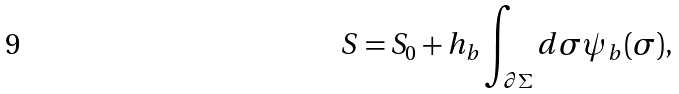<formula> <loc_0><loc_0><loc_500><loc_500>S = S _ { 0 } + h _ { b } \int _ { \partial \Sigma } d \sigma \psi _ { b } ( \sigma ) ,</formula> 